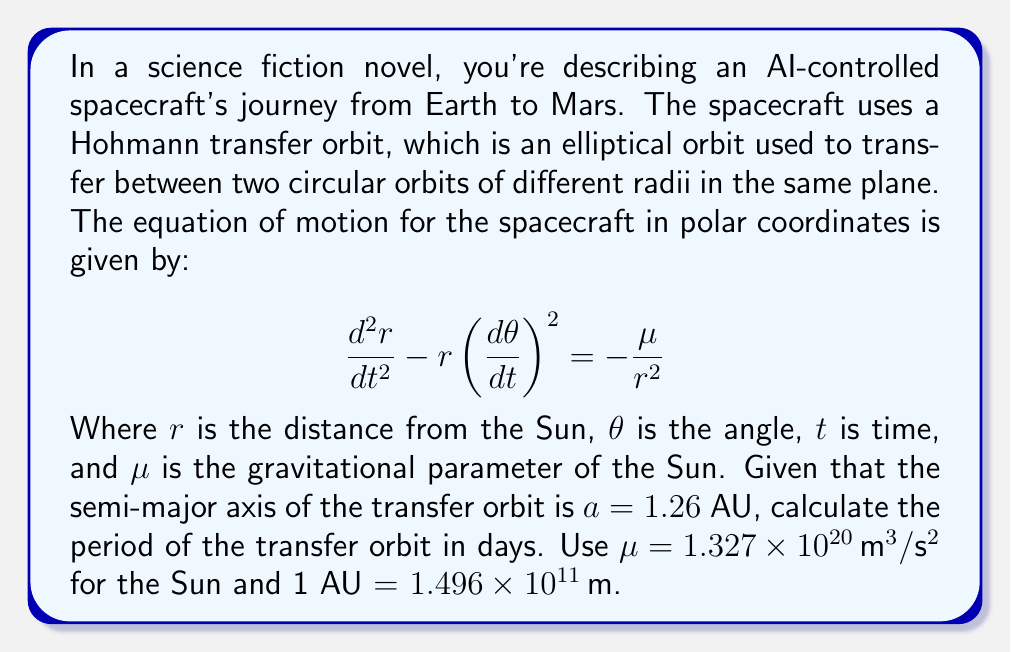Provide a solution to this math problem. To solve this problem, we'll use Kepler's Third Law of Planetary Motion, which relates the orbital period to the semi-major axis of an elliptical orbit. The steps are as follows:

1) Kepler's Third Law states that:

   $$T^2 = \frac{4\pi^2}{\mu}a^3$$

   Where $T$ is the orbital period, $\mu$ is the gravitational parameter, and $a$ is the semi-major axis.

2) We're given $a = 1.26$ AU. We need to convert this to meters:

   $$a = 1.26 \times (1.496 \times 10^{11}) = 1.88496 \times 10^{11} \, \text{m}$$

3) Now we can substitute the values into Kepler's Third Law:

   $$T^2 = \frac{4\pi^2}{1.327 \times 10^{20}} (1.88496 \times 10^{11})^3$$

4) Let's calculate this step by step:
   
   $$T^2 = \frac{4\pi^2}{1.327 \times 10^{20}} \times 6.70279 \times 10^{33}$$
   
   $$T^2 = 6.31724 \times 10^{14}$$

5) Taking the square root of both sides:

   $$T = \sqrt{6.31724 \times 10^{14}} = 7.94811 \times 10^7 \, \text{seconds}$$

6) Convert this to days:

   $$T = \frac{7.94811 \times 10^7}{86400} = 920.0 \, \text{days}$$

Thus, the period of the transfer orbit is approximately 920.0 days.
Answer: 920.0 days 